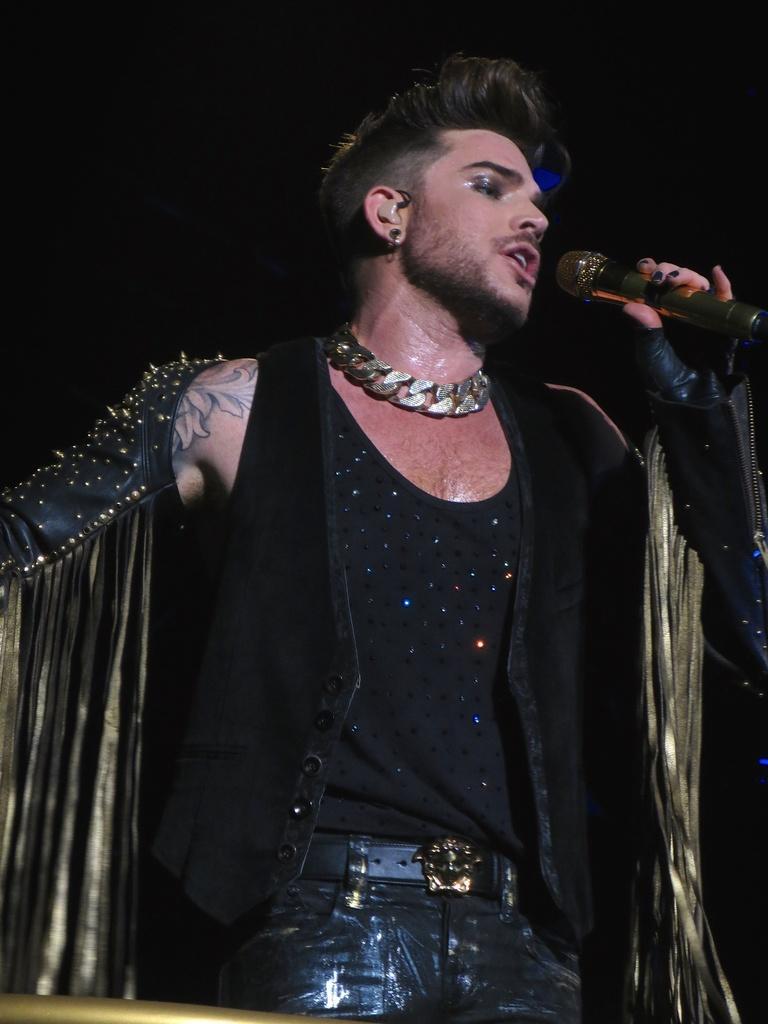Describe this image in one or two sentences. In this image we can see there is a boy wearing a black shirt and holding a mike in his hand is singing. 